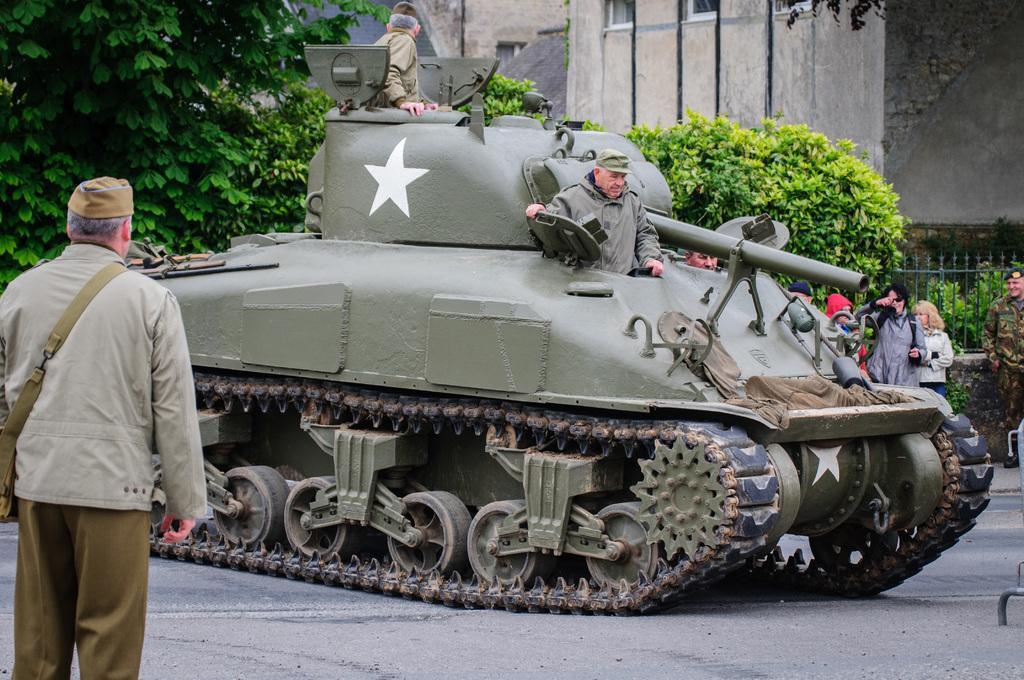Please provide a concise description of this image. There is a man standing and we can see people in a tank and road. In the background we can see people,fence,trees and wall. 